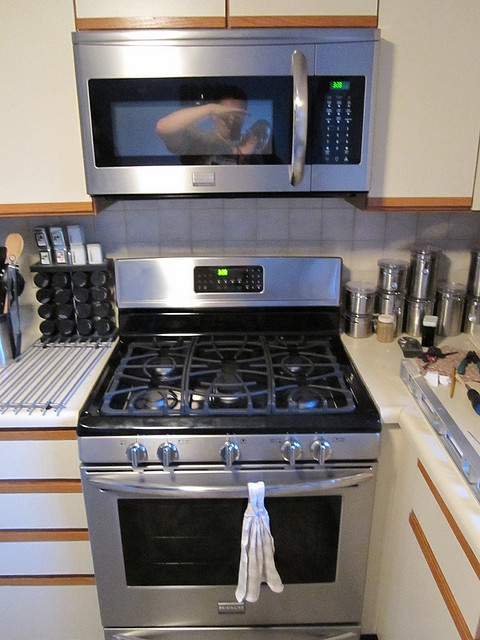Describe the objects in this image and their specific colors. I can see oven in tan, black, gray, and darkgray tones, microwave in tan, black, gray, and darkgray tones, people in tan, gray, black, and darkgray tones, people in tan, gray, black, and darkblue tones, and spoon in tan and gray tones in this image. 